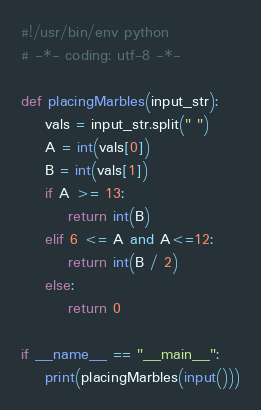<code> <loc_0><loc_0><loc_500><loc_500><_Python_>#!/usr/bin/env python
# -*- coding: utf-8 -*-

def placingMarbles(input_str):
    vals = input_str.split(" ")
    A = int(vals[0])
    B = int(vals[1])
    if A >= 13:
        return int(B)
    elif 6 <= A and A<=12:
        return int(B / 2)
    else:
        return 0

if __name__ == "__main__":
    print(placingMarbles(input()))
</code> 